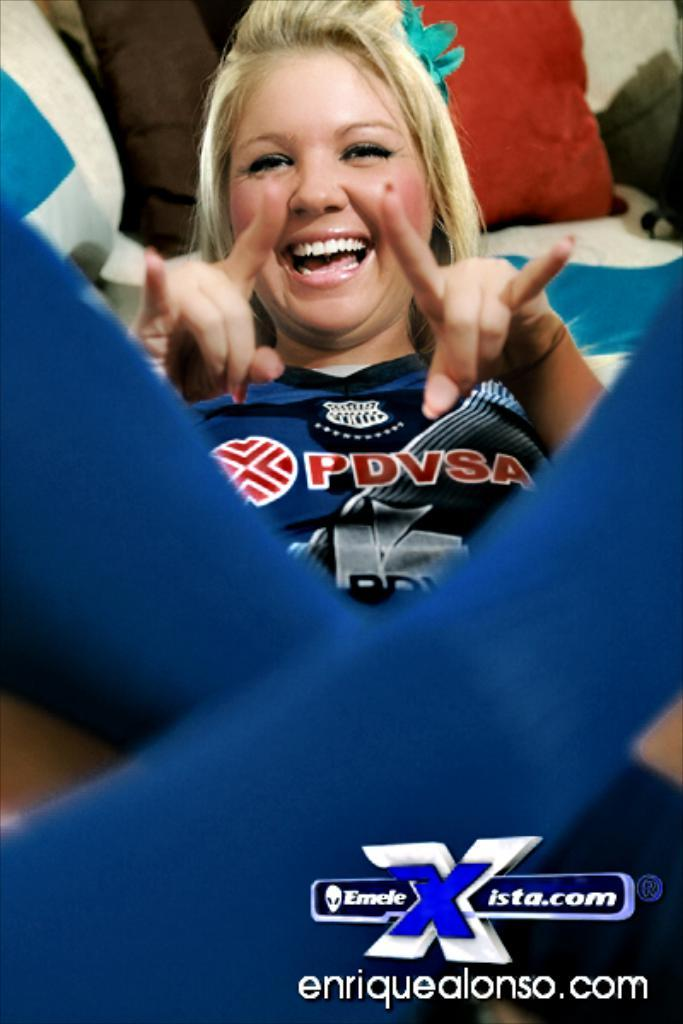<image>
Offer a succinct explanation of the picture presented. the lady with blond hair is wearing a PDVSA jersey 